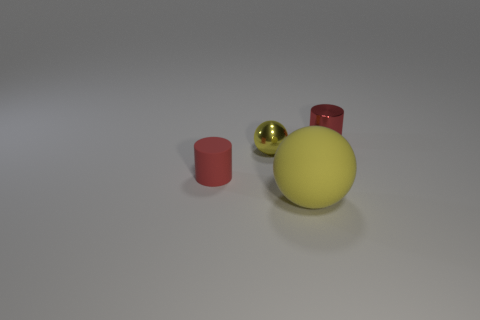What is the material of the object that is right of the tiny rubber cylinder and in front of the yellow metallic thing?
Provide a succinct answer. Rubber. Are there any red metallic spheres that have the same size as the red matte cylinder?
Your response must be concise. No. How many yellow matte objects are there?
Give a very brief answer. 1. How many red cylinders are to the left of the large yellow sphere?
Your response must be concise. 1. Is the material of the big ball the same as the small yellow ball?
Your answer should be very brief. No. What number of things are both to the right of the rubber cylinder and behind the big yellow sphere?
Offer a very short reply. 2. What number of other objects are there of the same color as the large rubber sphere?
Your response must be concise. 1. What number of yellow things are small balls or spheres?
Give a very brief answer. 2. How big is the yellow matte object?
Make the answer very short. Large. What number of metal objects are either big things or red cylinders?
Provide a succinct answer. 1. 